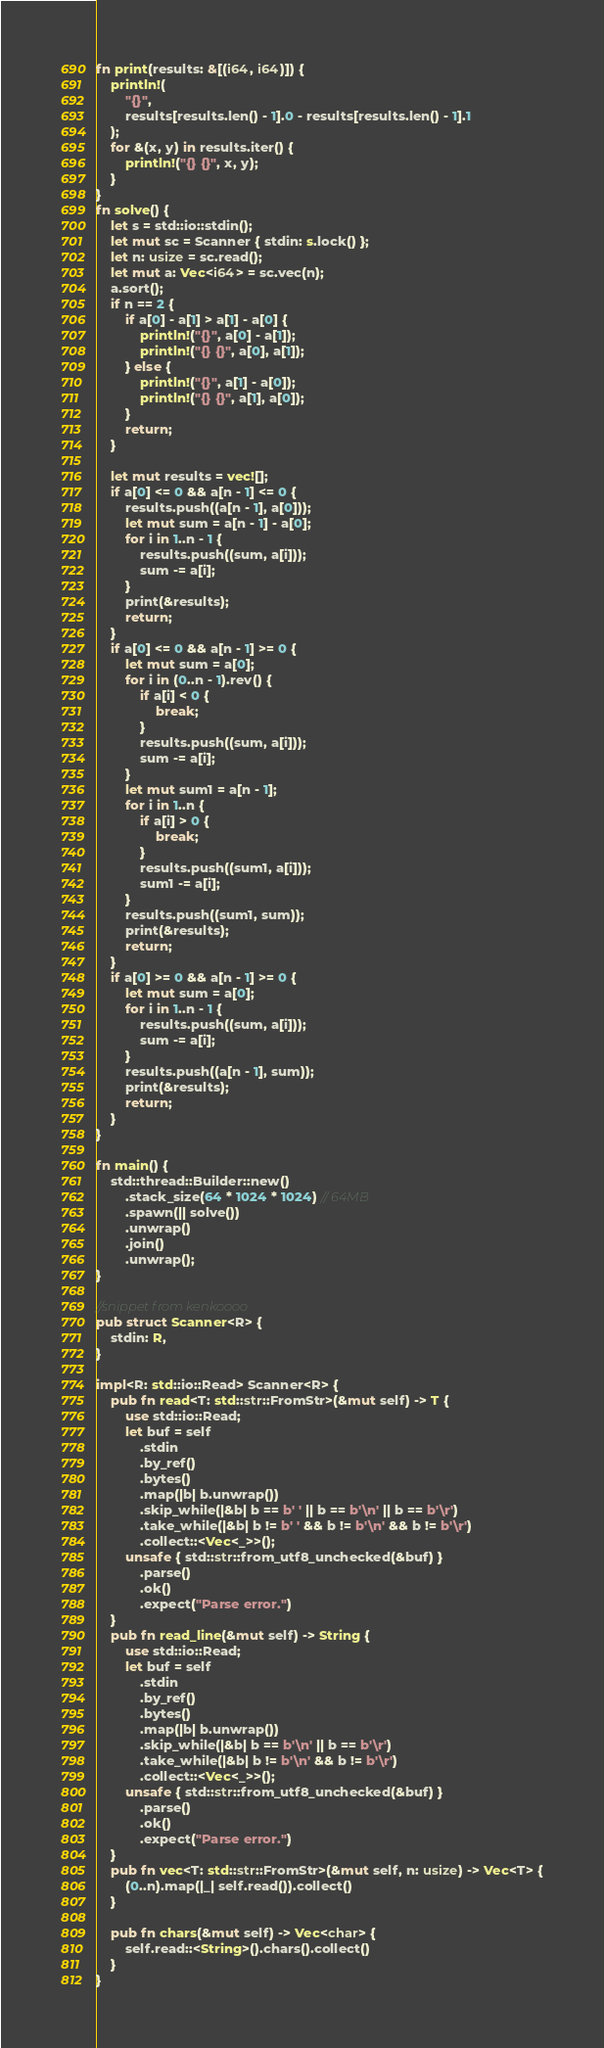<code> <loc_0><loc_0><loc_500><loc_500><_Rust_>fn print(results: &[(i64, i64)]) {
    println!(
        "{}",
        results[results.len() - 1].0 - results[results.len() - 1].1
    );
    for &(x, y) in results.iter() {
        println!("{} {}", x, y);
    }
}
fn solve() {
    let s = std::io::stdin();
    let mut sc = Scanner { stdin: s.lock() };
    let n: usize = sc.read();
    let mut a: Vec<i64> = sc.vec(n);
    a.sort();
    if n == 2 {
        if a[0] - a[1] > a[1] - a[0] {
            println!("{}", a[0] - a[1]);
            println!("{} {}", a[0], a[1]);
        } else {
            println!("{}", a[1] - a[0]);
            println!("{} {}", a[1], a[0]);
        }
        return;
    }

    let mut results = vec![];
    if a[0] <= 0 && a[n - 1] <= 0 {
        results.push((a[n - 1], a[0]));
        let mut sum = a[n - 1] - a[0];
        for i in 1..n - 1 {
            results.push((sum, a[i]));
            sum -= a[i];
        }
        print(&results);
        return;
    }
    if a[0] <= 0 && a[n - 1] >= 0 {
        let mut sum = a[0];
        for i in (0..n - 1).rev() {
            if a[i] < 0 {
                break;
            }
            results.push((sum, a[i]));
            sum -= a[i];
        }
        let mut sum1 = a[n - 1];
        for i in 1..n {
            if a[i] > 0 {
                break;
            }
            results.push((sum1, a[i]));
            sum1 -= a[i];
        }
        results.push((sum1, sum));
        print(&results);
        return;
    }
    if a[0] >= 0 && a[n - 1] >= 0 {
        let mut sum = a[0];
        for i in 1..n - 1 {
            results.push((sum, a[i]));
            sum -= a[i];
        }
        results.push((a[n - 1], sum));
        print(&results);
        return;
    }
}

fn main() {
    std::thread::Builder::new()
        .stack_size(64 * 1024 * 1024) // 64MB
        .spawn(|| solve())
        .unwrap()
        .join()
        .unwrap();
}

//snippet from kenkoooo
pub struct Scanner<R> {
    stdin: R,
}

impl<R: std::io::Read> Scanner<R> {
    pub fn read<T: std::str::FromStr>(&mut self) -> T {
        use std::io::Read;
        let buf = self
            .stdin
            .by_ref()
            .bytes()
            .map(|b| b.unwrap())
            .skip_while(|&b| b == b' ' || b == b'\n' || b == b'\r')
            .take_while(|&b| b != b' ' && b != b'\n' && b != b'\r')
            .collect::<Vec<_>>();
        unsafe { std::str::from_utf8_unchecked(&buf) }
            .parse()
            .ok()
            .expect("Parse error.")
    }
    pub fn read_line(&mut self) -> String {
        use std::io::Read;
        let buf = self
            .stdin
            .by_ref()
            .bytes()
            .map(|b| b.unwrap())
            .skip_while(|&b| b == b'\n' || b == b'\r')
            .take_while(|&b| b != b'\n' && b != b'\r')
            .collect::<Vec<_>>();
        unsafe { std::str::from_utf8_unchecked(&buf) }
            .parse()
            .ok()
            .expect("Parse error.")
    }
    pub fn vec<T: std::str::FromStr>(&mut self, n: usize) -> Vec<T> {
        (0..n).map(|_| self.read()).collect()
    }

    pub fn chars(&mut self) -> Vec<char> {
        self.read::<String>().chars().collect()
    }
}
</code> 